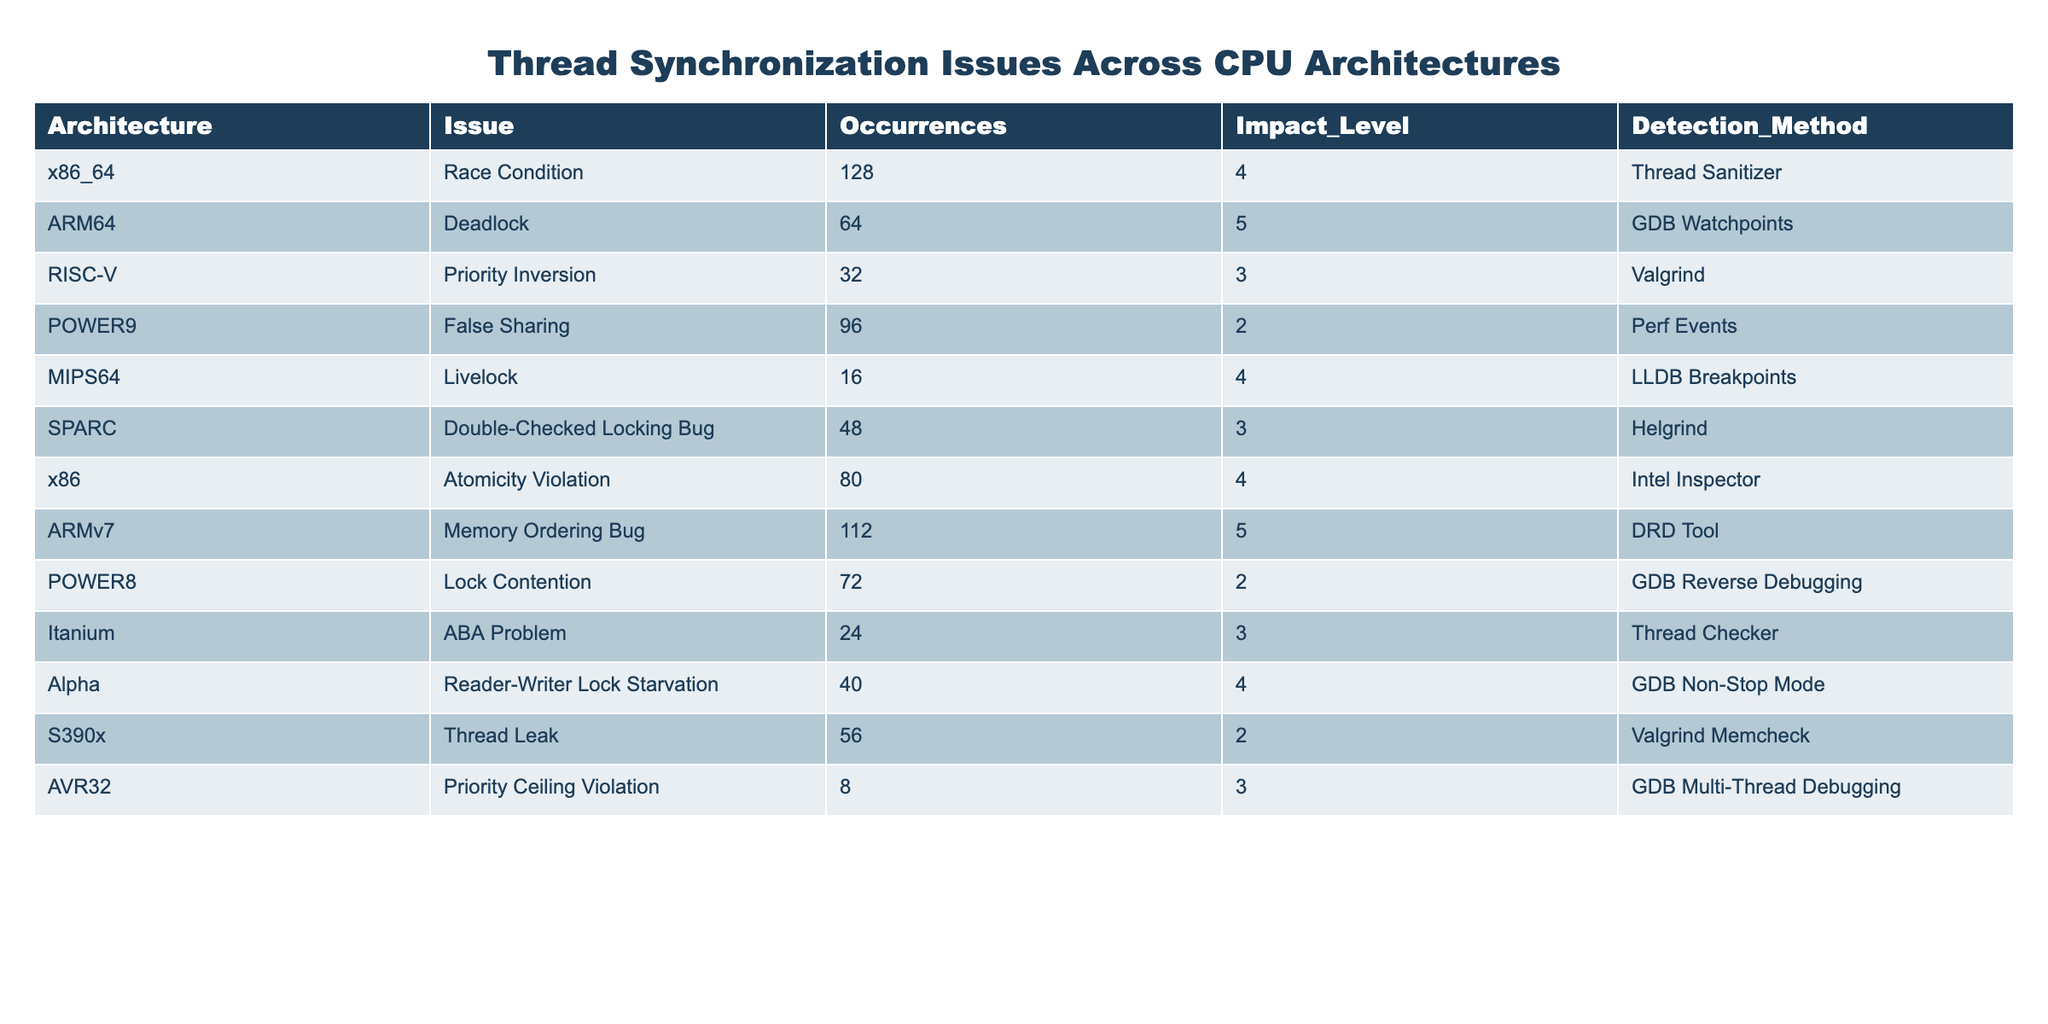What is the issue with the highest impact level on the x86 architecture? The x86 architecture has an Atomicity Violation issue with an impact level of 4. By scanning the table, I identify that the highest impact level for this architecture is indeed 4, which corresponds to its issue.
Answer: Atomicity Violation How many occurrences of the Deadlock issue were detected in ARM64? The table indicates that ARM64 has 64 occurrences of the Deadlock issue. I simply look for the row corresponding to ARM64 and locate the value in the Occurrences column.
Answer: 64 What is the average impact level of all issues listed for the various architectures? To find the average impact level, I sum all impact levels (4 + 5 + 3 + 2 + 4 + 3 + 4 + 5 + 2 + 3 + 4 + 2 + 3 = 46), and since there are 13 issues, I divide the total by 13 (46/13 = 3.54). Thus, the average impact level is approximately 3.54.
Answer: 3.54 Which architecture has the least occurrences of thread synchronization issues? The architecture with the least occurrences is AVR32, which shows only 8 occurrences for Priority Ceiling Violation. I compare the Occurrences column across all architectures to identify this.
Answer: AVR32 Is there an architecture that has a detection method unique to it? Yes, AVR32 uses GDB Multi-Thread Debugging, which isn't repeated for any other architecture in the table. I search through the Detection Method column for any unique entries.
Answer: Yes How many issues have an impact level greater than 3? I count the issues with an impact level greater than 3, which are Race Condition, Deadlock, Atomicity Violation, Memory Ordering Bug, Reader-Writer Lock Starvation, and Livelock. This gives a total of 6 issues.
Answer: 6 What is the difference in occurrences between the Deadlock issue and the Livelock issue? The Deadlock issue has 64 occurrences, while the Livelock issue has 16 occurrences. The difference is calculated as 64 - 16 = 48 occurrences.
Answer: 48 What percentage of the total occurrences is due to the Race Condition issue? The total occurrences across all issues is 64 + 16 + 96 + 128 + 32 + 48 + 80 + 112 + 72 + 24 + 40 + 56 + 8 = 712. The Race Condition has 128 occurrences. To find the percentage, I use (128/712)*100 = 17.95%, which rounds to approximately 18%.
Answer: 18% Which issue has the most occurrences and what is its impact level? The issue with the most occurrences is Race Condition, with 128 occurrences and an impact level of 4. I identify this by scanning the Occurrences column and locating the maximum value.
Answer: Race Condition, 4 Is it true that all architectures have at least two issues reported? No, AVR32 only has one reported issue (Priority Ceiling Violation). I check the number of reported issues for each architecture and find that AVR32 does not meet the criteria.
Answer: No What is the total number of occurrences for issues with an impact level of 2? The issues with an impact level of 2 are False Sharing, Lock Contention, and Thread Leak, with occurrences of 96, 72, and 56 respectively. Summing these gives 96 + 72 + 56 = 224 occurrences.
Answer: 224 Which detection method is utilized for the Memory Ordering Bug on ARMv7? The Memory Ordering Bug on ARMv7 utilizes the DRD Tool as its detection method. I refer to the row corresponding to ARMv7 and find the relevant detection method in the table.
Answer: DRD Tool 